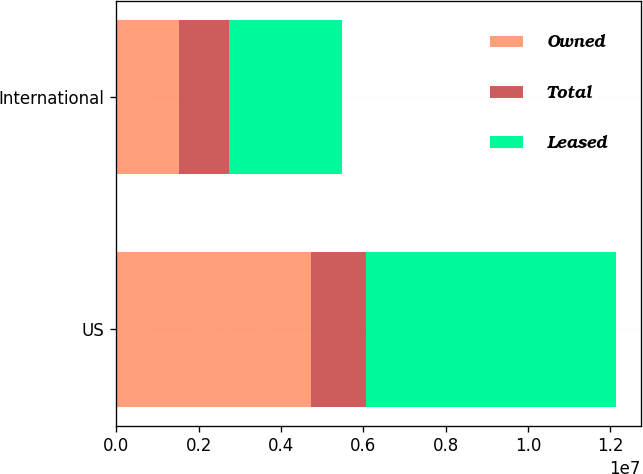<chart> <loc_0><loc_0><loc_500><loc_500><stacked_bar_chart><ecel><fcel>US<fcel>International<nl><fcel>Owned<fcel>4.739e+06<fcel>1.512e+06<nl><fcel>Total<fcel>1.329e+06<fcel>1.227e+06<nl><fcel>Leased<fcel>6.068e+06<fcel>2.739e+06<nl></chart> 